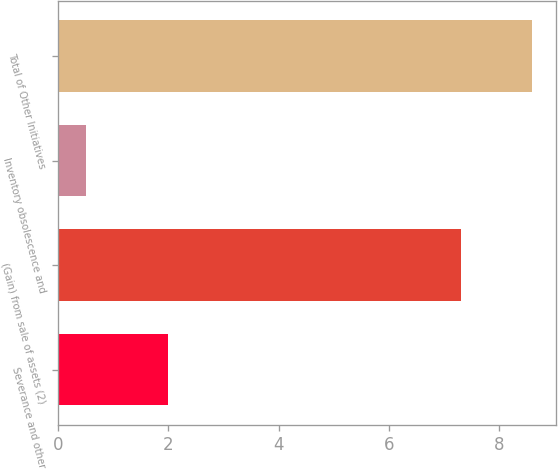Convert chart to OTSL. <chart><loc_0><loc_0><loc_500><loc_500><bar_chart><fcel>Severance and other<fcel>(Gain) from sale of assets (2)<fcel>Inventory obsolescence and<fcel>Total of Other Initiatives<nl><fcel>2<fcel>7.3<fcel>0.5<fcel>8.6<nl></chart> 